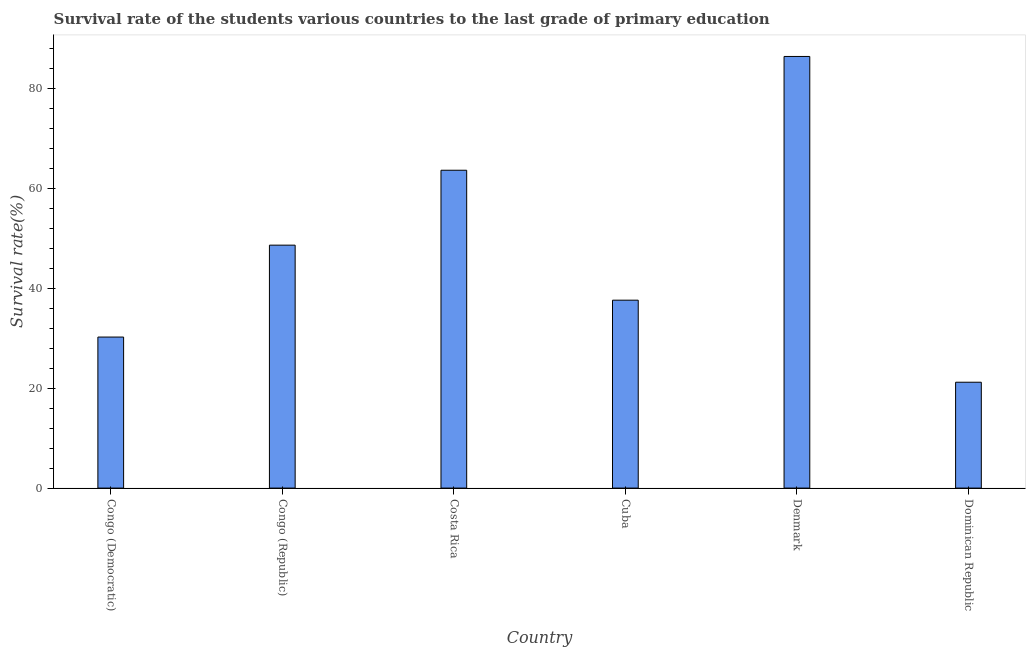Does the graph contain any zero values?
Offer a very short reply. No. Does the graph contain grids?
Make the answer very short. No. What is the title of the graph?
Give a very brief answer. Survival rate of the students various countries to the last grade of primary education. What is the label or title of the Y-axis?
Provide a short and direct response. Survival rate(%). What is the survival rate in primary education in Dominican Republic?
Your answer should be compact. 21.18. Across all countries, what is the maximum survival rate in primary education?
Your answer should be very brief. 86.37. Across all countries, what is the minimum survival rate in primary education?
Offer a terse response. 21.18. In which country was the survival rate in primary education maximum?
Provide a short and direct response. Denmark. In which country was the survival rate in primary education minimum?
Offer a very short reply. Dominican Republic. What is the sum of the survival rate in primary education?
Offer a terse response. 287.6. What is the difference between the survival rate in primary education in Costa Rica and Denmark?
Your response must be concise. -22.77. What is the average survival rate in primary education per country?
Provide a succinct answer. 47.93. What is the median survival rate in primary education?
Your answer should be compact. 43.11. Is the difference between the survival rate in primary education in Congo (Democratic) and Cuba greater than the difference between any two countries?
Your answer should be compact. No. What is the difference between the highest and the second highest survival rate in primary education?
Ensure brevity in your answer.  22.77. What is the difference between the highest and the lowest survival rate in primary education?
Provide a short and direct response. 65.19. In how many countries, is the survival rate in primary education greater than the average survival rate in primary education taken over all countries?
Keep it short and to the point. 3. How many countries are there in the graph?
Make the answer very short. 6. What is the difference between two consecutive major ticks on the Y-axis?
Ensure brevity in your answer.  20. What is the Survival rate(%) in Congo (Democratic)?
Your answer should be very brief. 30.22. What is the Survival rate(%) in Congo (Republic)?
Provide a succinct answer. 48.61. What is the Survival rate(%) in Costa Rica?
Offer a terse response. 63.6. What is the Survival rate(%) of Cuba?
Give a very brief answer. 37.6. What is the Survival rate(%) in Denmark?
Offer a terse response. 86.37. What is the Survival rate(%) of Dominican Republic?
Make the answer very short. 21.18. What is the difference between the Survival rate(%) in Congo (Democratic) and Congo (Republic)?
Provide a succinct answer. -18.39. What is the difference between the Survival rate(%) in Congo (Democratic) and Costa Rica?
Offer a terse response. -33.38. What is the difference between the Survival rate(%) in Congo (Democratic) and Cuba?
Ensure brevity in your answer.  -7.38. What is the difference between the Survival rate(%) in Congo (Democratic) and Denmark?
Offer a very short reply. -56.15. What is the difference between the Survival rate(%) in Congo (Democratic) and Dominican Republic?
Offer a very short reply. 9.04. What is the difference between the Survival rate(%) in Congo (Republic) and Costa Rica?
Offer a terse response. -14.99. What is the difference between the Survival rate(%) in Congo (Republic) and Cuba?
Provide a succinct answer. 11.01. What is the difference between the Survival rate(%) in Congo (Republic) and Denmark?
Your answer should be very brief. -37.76. What is the difference between the Survival rate(%) in Congo (Republic) and Dominican Republic?
Offer a very short reply. 27.43. What is the difference between the Survival rate(%) in Costa Rica and Cuba?
Offer a very short reply. 26. What is the difference between the Survival rate(%) in Costa Rica and Denmark?
Provide a succinct answer. -22.77. What is the difference between the Survival rate(%) in Costa Rica and Dominican Republic?
Offer a terse response. 42.42. What is the difference between the Survival rate(%) in Cuba and Denmark?
Make the answer very short. -48.77. What is the difference between the Survival rate(%) in Cuba and Dominican Republic?
Give a very brief answer. 16.42. What is the difference between the Survival rate(%) in Denmark and Dominican Republic?
Make the answer very short. 65.19. What is the ratio of the Survival rate(%) in Congo (Democratic) to that in Congo (Republic)?
Offer a terse response. 0.62. What is the ratio of the Survival rate(%) in Congo (Democratic) to that in Costa Rica?
Offer a terse response. 0.47. What is the ratio of the Survival rate(%) in Congo (Democratic) to that in Cuba?
Provide a succinct answer. 0.8. What is the ratio of the Survival rate(%) in Congo (Democratic) to that in Denmark?
Make the answer very short. 0.35. What is the ratio of the Survival rate(%) in Congo (Democratic) to that in Dominican Republic?
Offer a terse response. 1.43. What is the ratio of the Survival rate(%) in Congo (Republic) to that in Costa Rica?
Offer a terse response. 0.76. What is the ratio of the Survival rate(%) in Congo (Republic) to that in Cuba?
Give a very brief answer. 1.29. What is the ratio of the Survival rate(%) in Congo (Republic) to that in Denmark?
Provide a short and direct response. 0.56. What is the ratio of the Survival rate(%) in Congo (Republic) to that in Dominican Republic?
Your response must be concise. 2.29. What is the ratio of the Survival rate(%) in Costa Rica to that in Cuba?
Offer a very short reply. 1.69. What is the ratio of the Survival rate(%) in Costa Rica to that in Denmark?
Keep it short and to the point. 0.74. What is the ratio of the Survival rate(%) in Costa Rica to that in Dominican Republic?
Keep it short and to the point. 3. What is the ratio of the Survival rate(%) in Cuba to that in Denmark?
Give a very brief answer. 0.43. What is the ratio of the Survival rate(%) in Cuba to that in Dominican Republic?
Your response must be concise. 1.77. What is the ratio of the Survival rate(%) in Denmark to that in Dominican Republic?
Offer a very short reply. 4.08. 